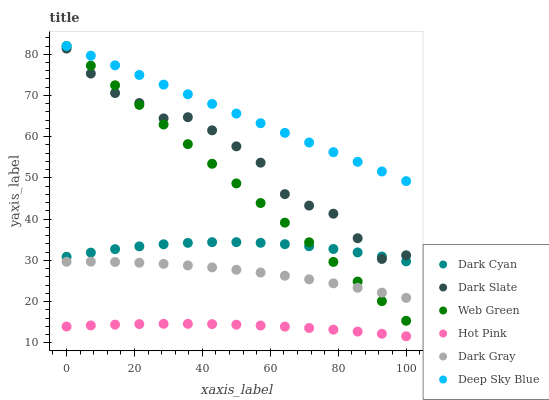Does Hot Pink have the minimum area under the curve?
Answer yes or no. Yes. Does Deep Sky Blue have the maximum area under the curve?
Answer yes or no. Yes. Does Web Green have the minimum area under the curve?
Answer yes or no. No. Does Web Green have the maximum area under the curve?
Answer yes or no. No. Is Deep Sky Blue the smoothest?
Answer yes or no. Yes. Is Dark Slate the roughest?
Answer yes or no. Yes. Is Web Green the smoothest?
Answer yes or no. No. Is Web Green the roughest?
Answer yes or no. No. Does Hot Pink have the lowest value?
Answer yes or no. Yes. Does Web Green have the lowest value?
Answer yes or no. No. Does Deep Sky Blue have the highest value?
Answer yes or no. Yes. Does Dark Gray have the highest value?
Answer yes or no. No. Is Hot Pink less than Dark Gray?
Answer yes or no. Yes. Is Deep Sky Blue greater than Dark Slate?
Answer yes or no. Yes. Does Web Green intersect Deep Sky Blue?
Answer yes or no. Yes. Is Web Green less than Deep Sky Blue?
Answer yes or no. No. Is Web Green greater than Deep Sky Blue?
Answer yes or no. No. Does Hot Pink intersect Dark Gray?
Answer yes or no. No. 